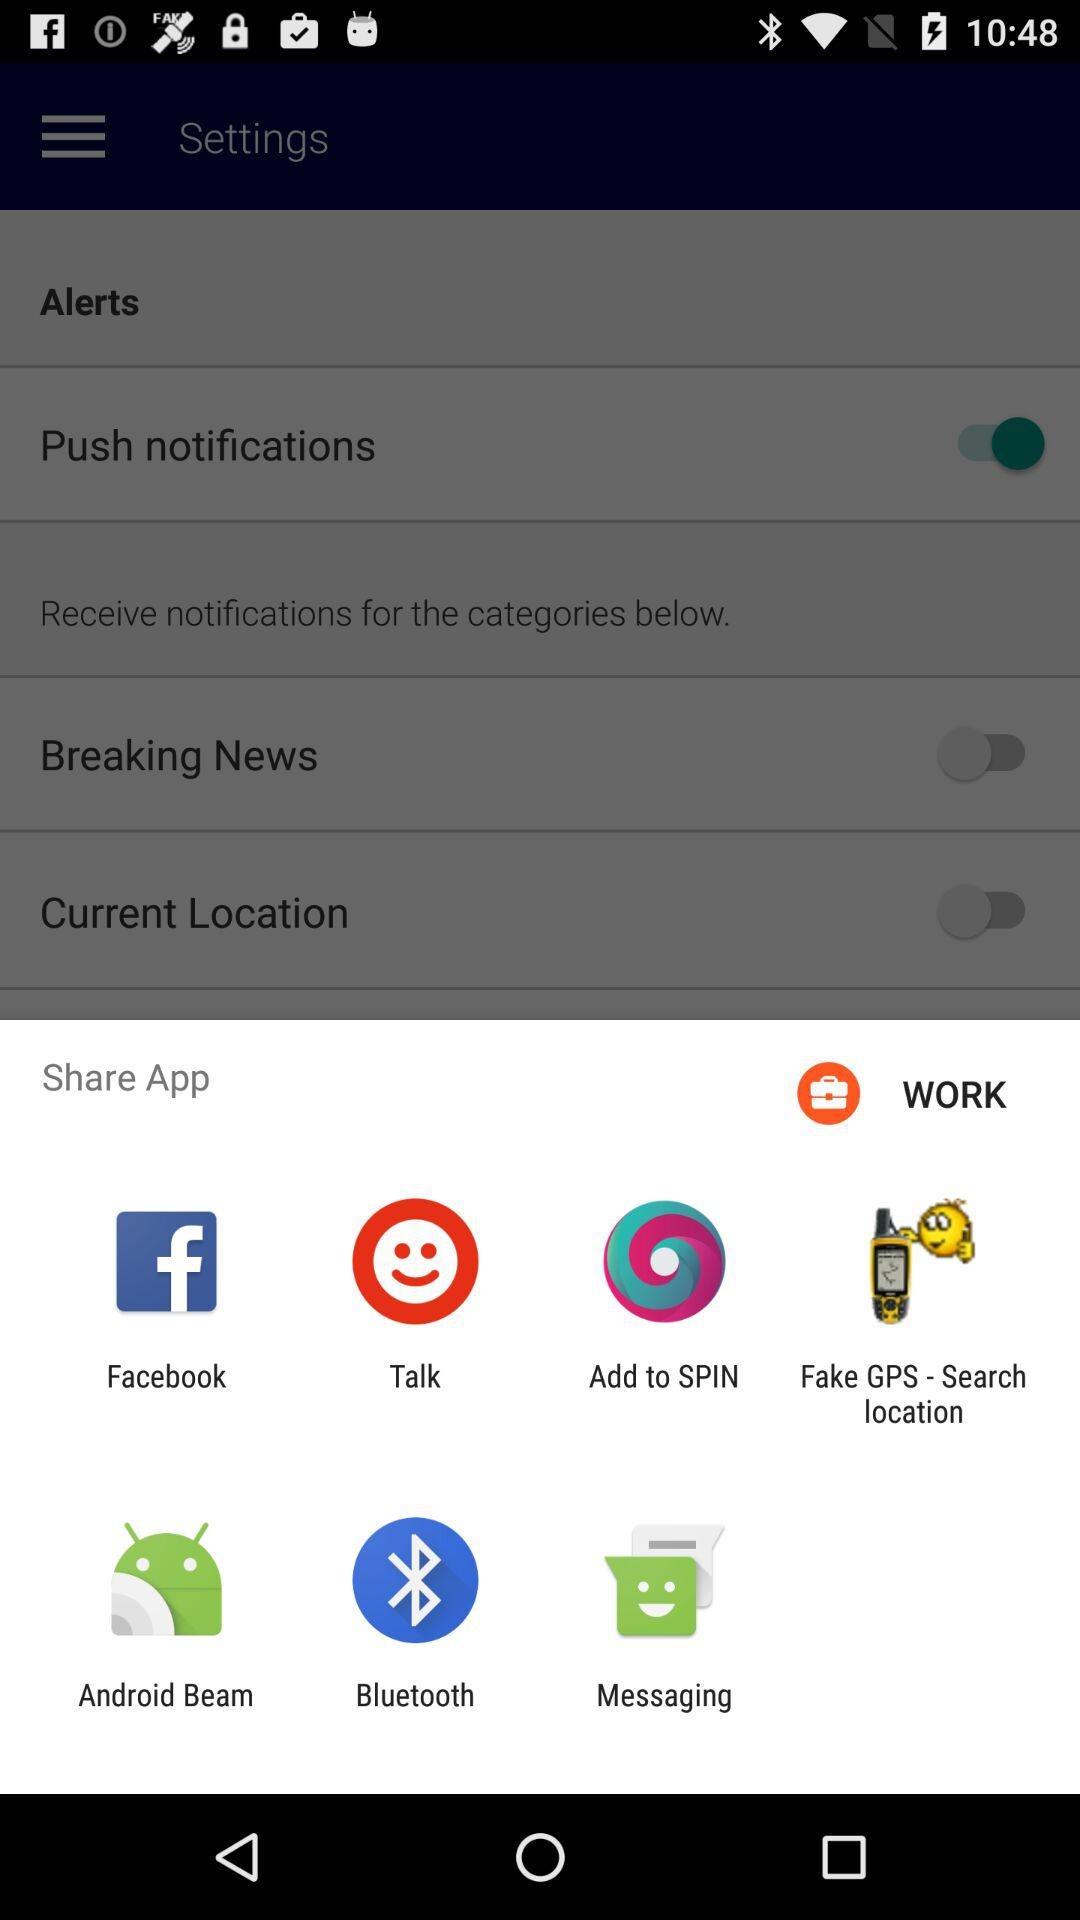What is the current status of the breaking news? The status is off. 